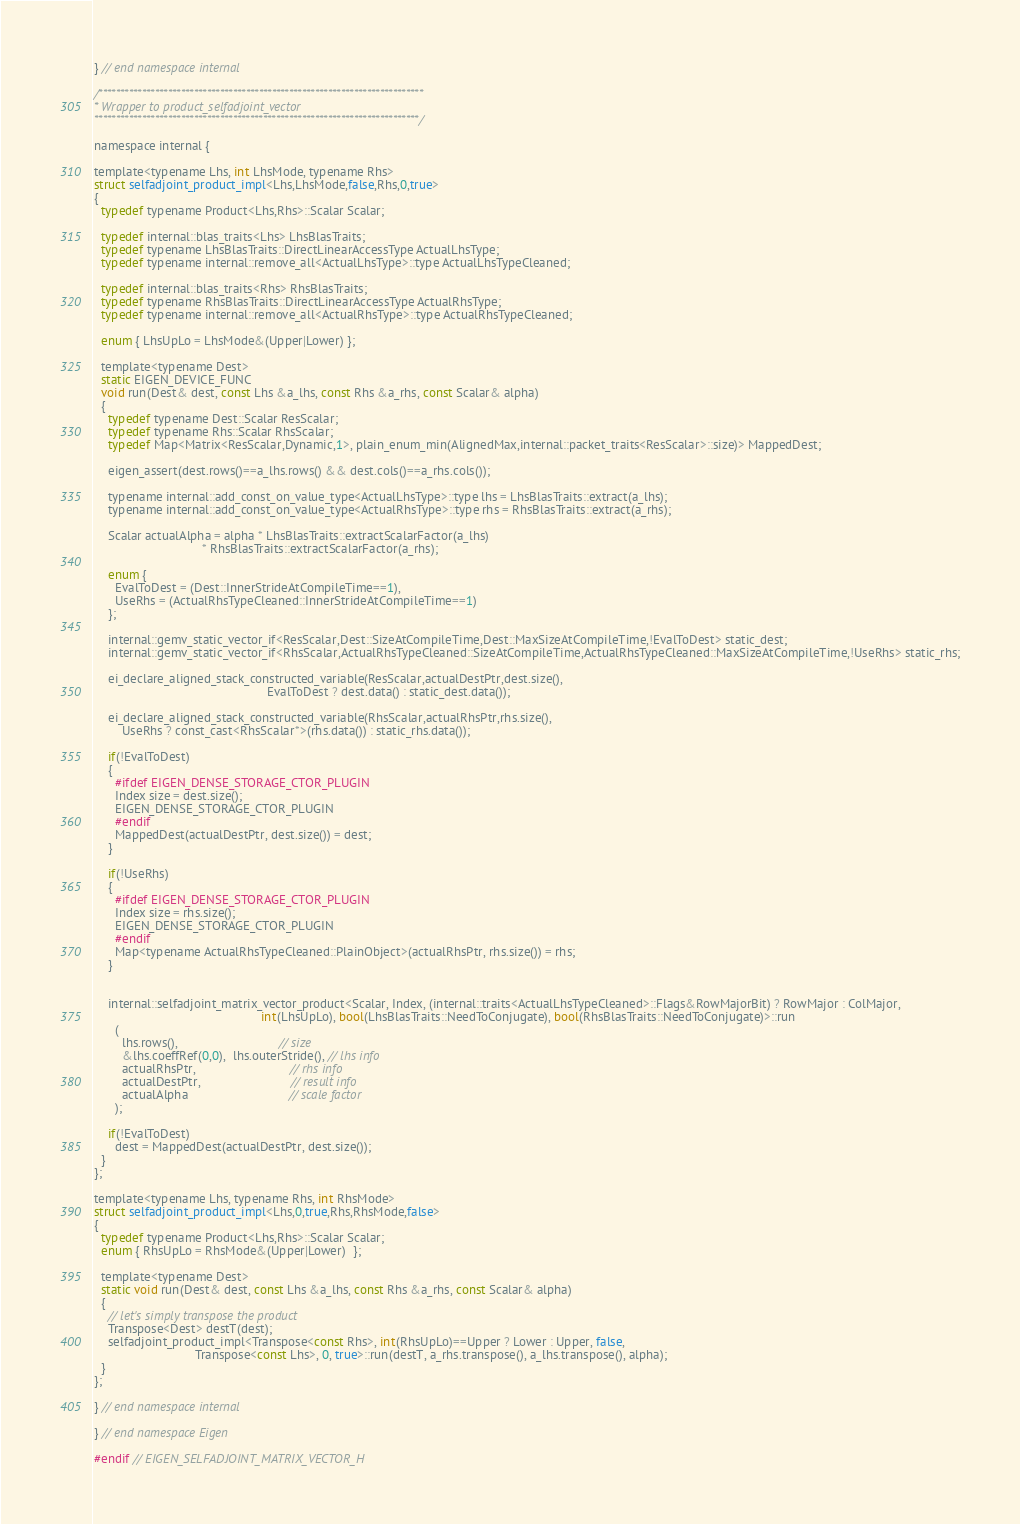<code> <loc_0><loc_0><loc_500><loc_500><_C_>} // end namespace internal 

/***************************************************************************
* Wrapper to product_selfadjoint_vector
***************************************************************************/

namespace internal {

template<typename Lhs, int LhsMode, typename Rhs>
struct selfadjoint_product_impl<Lhs,LhsMode,false,Rhs,0,true>
{
  typedef typename Product<Lhs,Rhs>::Scalar Scalar;
  
  typedef internal::blas_traits<Lhs> LhsBlasTraits;
  typedef typename LhsBlasTraits::DirectLinearAccessType ActualLhsType;
  typedef typename internal::remove_all<ActualLhsType>::type ActualLhsTypeCleaned;
  
  typedef internal::blas_traits<Rhs> RhsBlasTraits;
  typedef typename RhsBlasTraits::DirectLinearAccessType ActualRhsType;
  typedef typename internal::remove_all<ActualRhsType>::type ActualRhsTypeCleaned;

  enum { LhsUpLo = LhsMode&(Upper|Lower) };

  template<typename Dest>
  static EIGEN_DEVICE_FUNC
  void run(Dest& dest, const Lhs &a_lhs, const Rhs &a_rhs, const Scalar& alpha)
  {
    typedef typename Dest::Scalar ResScalar;
    typedef typename Rhs::Scalar RhsScalar;
    typedef Map<Matrix<ResScalar,Dynamic,1>, plain_enum_min(AlignedMax,internal::packet_traits<ResScalar>::size)> MappedDest;
    
    eigen_assert(dest.rows()==a_lhs.rows() && dest.cols()==a_rhs.cols());

    typename internal::add_const_on_value_type<ActualLhsType>::type lhs = LhsBlasTraits::extract(a_lhs);
    typename internal::add_const_on_value_type<ActualRhsType>::type rhs = RhsBlasTraits::extract(a_rhs);

    Scalar actualAlpha = alpha * LhsBlasTraits::extractScalarFactor(a_lhs)
                               * RhsBlasTraits::extractScalarFactor(a_rhs);

    enum {
      EvalToDest = (Dest::InnerStrideAtCompileTime==1),
      UseRhs = (ActualRhsTypeCleaned::InnerStrideAtCompileTime==1)
    };
    
    internal::gemv_static_vector_if<ResScalar,Dest::SizeAtCompileTime,Dest::MaxSizeAtCompileTime,!EvalToDest> static_dest;
    internal::gemv_static_vector_if<RhsScalar,ActualRhsTypeCleaned::SizeAtCompileTime,ActualRhsTypeCleaned::MaxSizeAtCompileTime,!UseRhs> static_rhs;

    ei_declare_aligned_stack_constructed_variable(ResScalar,actualDestPtr,dest.size(),
                                                  EvalToDest ? dest.data() : static_dest.data());
                                                  
    ei_declare_aligned_stack_constructed_variable(RhsScalar,actualRhsPtr,rhs.size(),
        UseRhs ? const_cast<RhsScalar*>(rhs.data()) : static_rhs.data());
    
    if(!EvalToDest)
    {
      #ifdef EIGEN_DENSE_STORAGE_CTOR_PLUGIN
      Index size = dest.size();
      EIGEN_DENSE_STORAGE_CTOR_PLUGIN
      #endif
      MappedDest(actualDestPtr, dest.size()) = dest;
    }
      
    if(!UseRhs)
    {
      #ifdef EIGEN_DENSE_STORAGE_CTOR_PLUGIN
      Index size = rhs.size();
      EIGEN_DENSE_STORAGE_CTOR_PLUGIN
      #endif
      Map<typename ActualRhsTypeCleaned::PlainObject>(actualRhsPtr, rhs.size()) = rhs;
    }
      
      
    internal::selfadjoint_matrix_vector_product<Scalar, Index, (internal::traits<ActualLhsTypeCleaned>::Flags&RowMajorBit) ? RowMajor : ColMajor,
                                                int(LhsUpLo), bool(LhsBlasTraits::NeedToConjugate), bool(RhsBlasTraits::NeedToConjugate)>::run
      (
        lhs.rows(),                             // size
        &lhs.coeffRef(0,0),  lhs.outerStride(), // lhs info
        actualRhsPtr,                           // rhs info
        actualDestPtr,                          // result info
        actualAlpha                             // scale factor
      );
    
    if(!EvalToDest)
      dest = MappedDest(actualDestPtr, dest.size());
  }
};

template<typename Lhs, typename Rhs, int RhsMode>
struct selfadjoint_product_impl<Lhs,0,true,Rhs,RhsMode,false>
{
  typedef typename Product<Lhs,Rhs>::Scalar Scalar;
  enum { RhsUpLo = RhsMode&(Upper|Lower)  };

  template<typename Dest>
  static void run(Dest& dest, const Lhs &a_lhs, const Rhs &a_rhs, const Scalar& alpha)
  {
    // let's simply transpose the product
    Transpose<Dest> destT(dest);
    selfadjoint_product_impl<Transpose<const Rhs>, int(RhsUpLo)==Upper ? Lower : Upper, false,
                             Transpose<const Lhs>, 0, true>::run(destT, a_rhs.transpose(), a_lhs.transpose(), alpha);
  }
};

} // end namespace internal

} // end namespace Eigen

#endif // EIGEN_SELFADJOINT_MATRIX_VECTOR_H
</code> 